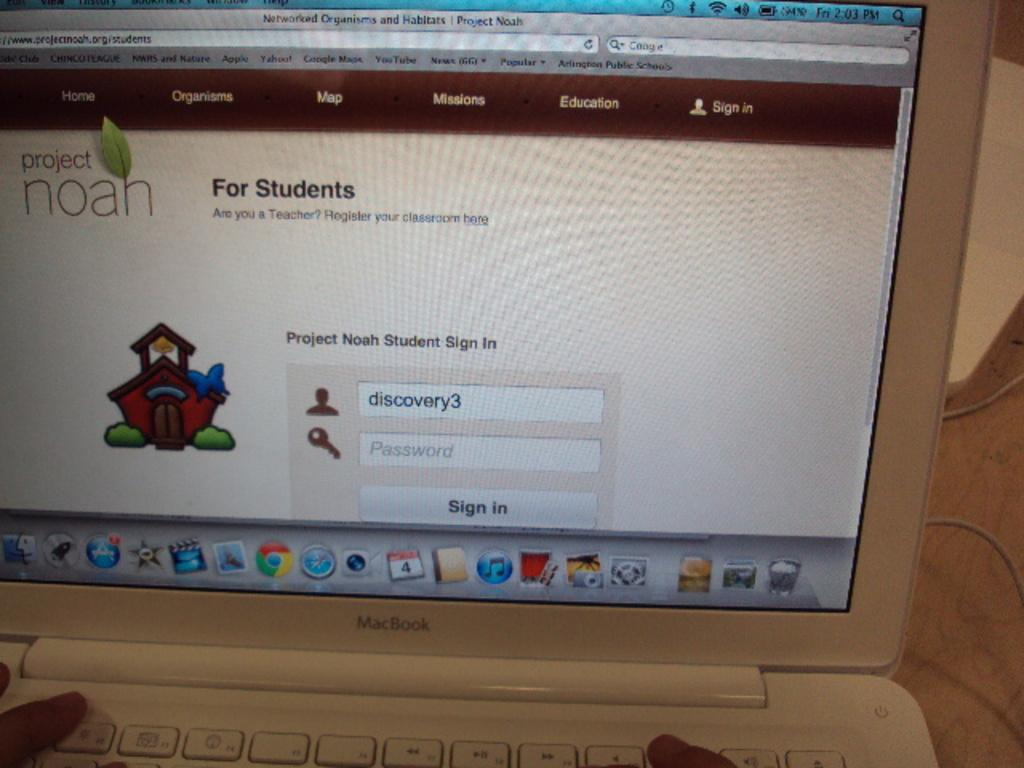<image>
Relay a brief, clear account of the picture shown. a white MACBook open to a site for Project Noah 